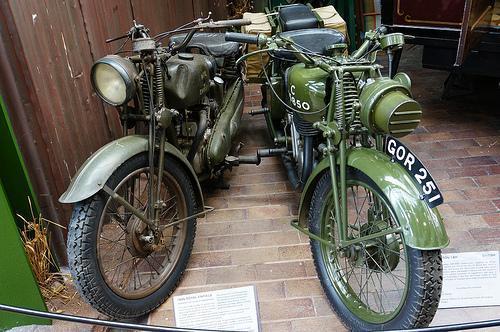How many seats on each motorcycle?
Give a very brief answer. 1. How many motorcycles are there?
Give a very brief answer. 2. 